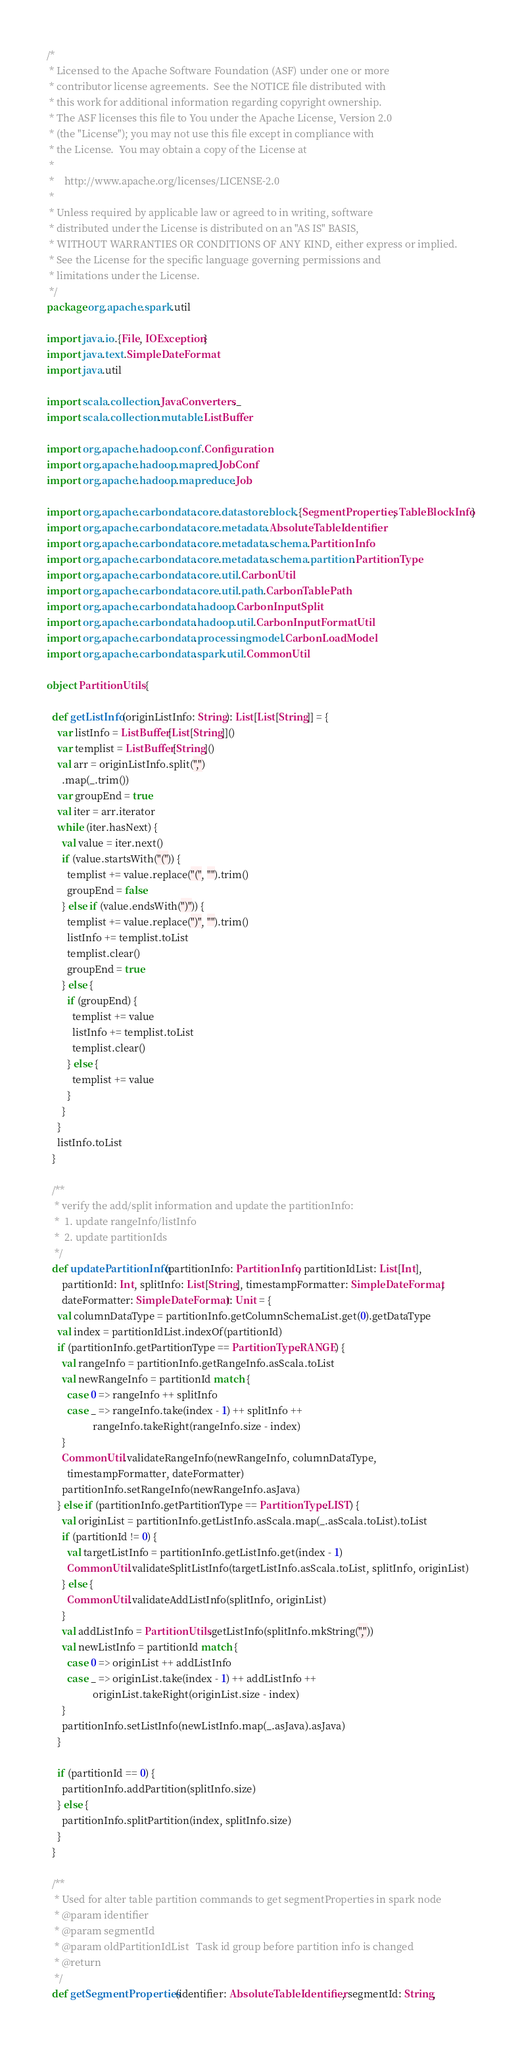Convert code to text. <code><loc_0><loc_0><loc_500><loc_500><_Scala_>/*
 * Licensed to the Apache Software Foundation (ASF) under one or more
 * contributor license agreements.  See the NOTICE file distributed with
 * this work for additional information regarding copyright ownership.
 * The ASF licenses this file to You under the Apache License, Version 2.0
 * (the "License"); you may not use this file except in compliance with
 * the License.  You may obtain a copy of the License at
 *
 *    http://www.apache.org/licenses/LICENSE-2.0
 *
 * Unless required by applicable law or agreed to in writing, software
 * distributed under the License is distributed on an "AS IS" BASIS,
 * WITHOUT WARRANTIES OR CONDITIONS OF ANY KIND, either express or implied.
 * See the License for the specific language governing permissions and
 * limitations under the License.
 */
package org.apache.spark.util

import java.io.{File, IOException}
import java.text.SimpleDateFormat
import java.util

import scala.collection.JavaConverters._
import scala.collection.mutable.ListBuffer

import org.apache.hadoop.conf.Configuration
import org.apache.hadoop.mapred.JobConf
import org.apache.hadoop.mapreduce.Job

import org.apache.carbondata.core.datastore.block.{SegmentProperties, TableBlockInfo}
import org.apache.carbondata.core.metadata.AbsoluteTableIdentifier
import org.apache.carbondata.core.metadata.schema.PartitionInfo
import org.apache.carbondata.core.metadata.schema.partition.PartitionType
import org.apache.carbondata.core.util.CarbonUtil
import org.apache.carbondata.core.util.path.CarbonTablePath
import org.apache.carbondata.hadoop.CarbonInputSplit
import org.apache.carbondata.hadoop.util.CarbonInputFormatUtil
import org.apache.carbondata.processing.model.CarbonLoadModel
import org.apache.carbondata.spark.util.CommonUtil

object PartitionUtils {

  def getListInfo(originListInfo: String): List[List[String]] = {
    var listInfo = ListBuffer[List[String]]()
    var templist = ListBuffer[String]()
    val arr = originListInfo.split(",")
      .map(_.trim())
    var groupEnd = true
    val iter = arr.iterator
    while (iter.hasNext) {
      val value = iter.next()
      if (value.startsWith("(")) {
        templist += value.replace("(", "").trim()
        groupEnd = false
      } else if (value.endsWith(")")) {
        templist += value.replace(")", "").trim()
        listInfo += templist.toList
        templist.clear()
        groupEnd = true
      } else {
        if (groupEnd) {
          templist += value
          listInfo += templist.toList
          templist.clear()
        } else {
          templist += value
        }
      }
    }
    listInfo.toList
  }

  /**
   * verify the add/split information and update the partitionInfo:
   *  1. update rangeInfo/listInfo
   *  2. update partitionIds
   */
  def updatePartitionInfo(partitionInfo: PartitionInfo, partitionIdList: List[Int],
      partitionId: Int, splitInfo: List[String], timestampFormatter: SimpleDateFormat,
      dateFormatter: SimpleDateFormat): Unit = {
    val columnDataType = partitionInfo.getColumnSchemaList.get(0).getDataType
    val index = partitionIdList.indexOf(partitionId)
    if (partitionInfo.getPartitionType == PartitionType.RANGE) {
      val rangeInfo = partitionInfo.getRangeInfo.asScala.toList
      val newRangeInfo = partitionId match {
        case 0 => rangeInfo ++ splitInfo
        case _ => rangeInfo.take(index - 1) ++ splitInfo ++
                  rangeInfo.takeRight(rangeInfo.size - index)
      }
      CommonUtil.validateRangeInfo(newRangeInfo, columnDataType,
        timestampFormatter, dateFormatter)
      partitionInfo.setRangeInfo(newRangeInfo.asJava)
    } else if (partitionInfo.getPartitionType == PartitionType.LIST) {
      val originList = partitionInfo.getListInfo.asScala.map(_.asScala.toList).toList
      if (partitionId != 0) {
        val targetListInfo = partitionInfo.getListInfo.get(index - 1)
        CommonUtil.validateSplitListInfo(targetListInfo.asScala.toList, splitInfo, originList)
      } else {
        CommonUtil.validateAddListInfo(splitInfo, originList)
      }
      val addListInfo = PartitionUtils.getListInfo(splitInfo.mkString(","))
      val newListInfo = partitionId match {
        case 0 => originList ++ addListInfo
        case _ => originList.take(index - 1) ++ addListInfo ++
                  originList.takeRight(originList.size - index)
      }
      partitionInfo.setListInfo(newListInfo.map(_.asJava).asJava)
    }

    if (partitionId == 0) {
      partitionInfo.addPartition(splitInfo.size)
    } else {
      partitionInfo.splitPartition(index, splitInfo.size)
    }
  }

  /**
   * Used for alter table partition commands to get segmentProperties in spark node
   * @param identifier
   * @param segmentId
   * @param oldPartitionIdList   Task id group before partition info is changed
   * @return
   */
  def getSegmentProperties(identifier: AbsoluteTableIdentifier, segmentId: String,</code> 